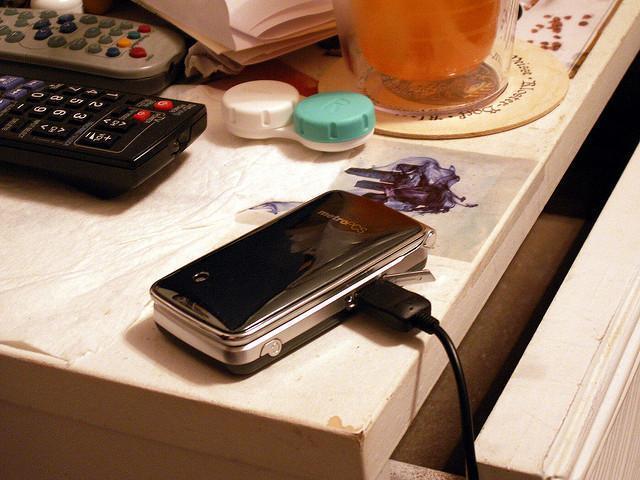How many remotes can you see?
Give a very brief answer. 2. How many people are in the image?
Give a very brief answer. 0. 